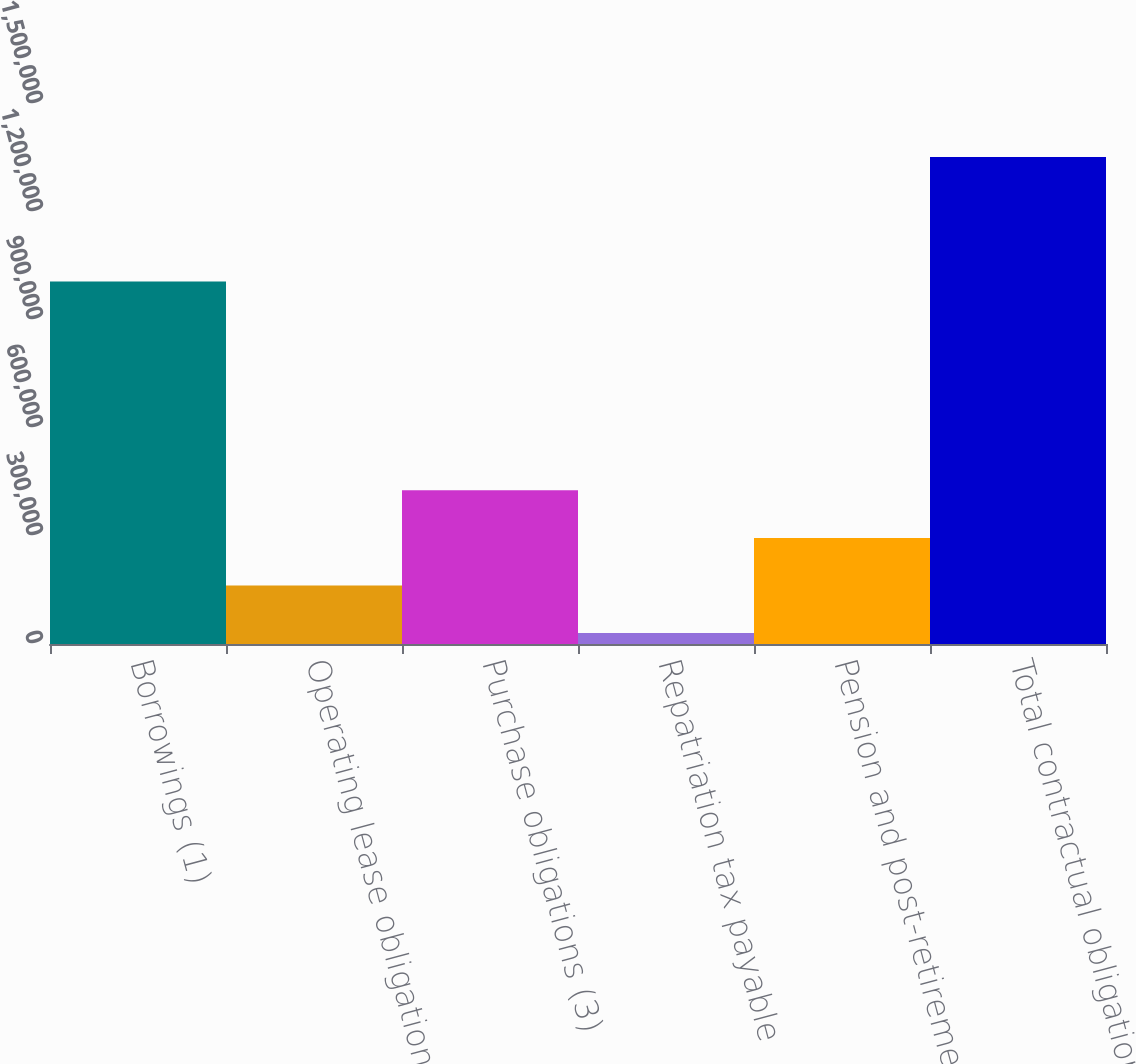<chart> <loc_0><loc_0><loc_500><loc_500><bar_chart><fcel>Borrowings (1)<fcel>Operating lease obligations<fcel>Purchase obligations (3)<fcel>Repatriation tax payable<fcel>Pension and post-retirement<fcel>Total contractual obligations<nl><fcel>1.00686e+06<fcel>162531<fcel>426990<fcel>30301<fcel>294761<fcel>1.3526e+06<nl></chart> 